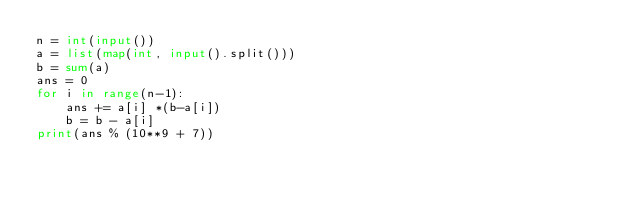<code> <loc_0><loc_0><loc_500><loc_500><_Python_>n = int(input())
a = list(map(int, input().split()))
b = sum(a)
ans = 0
for i in range(n-1):
    ans += a[i] *(b-a[i])
    b = b - a[i]
print(ans % (10**9 + 7))</code> 